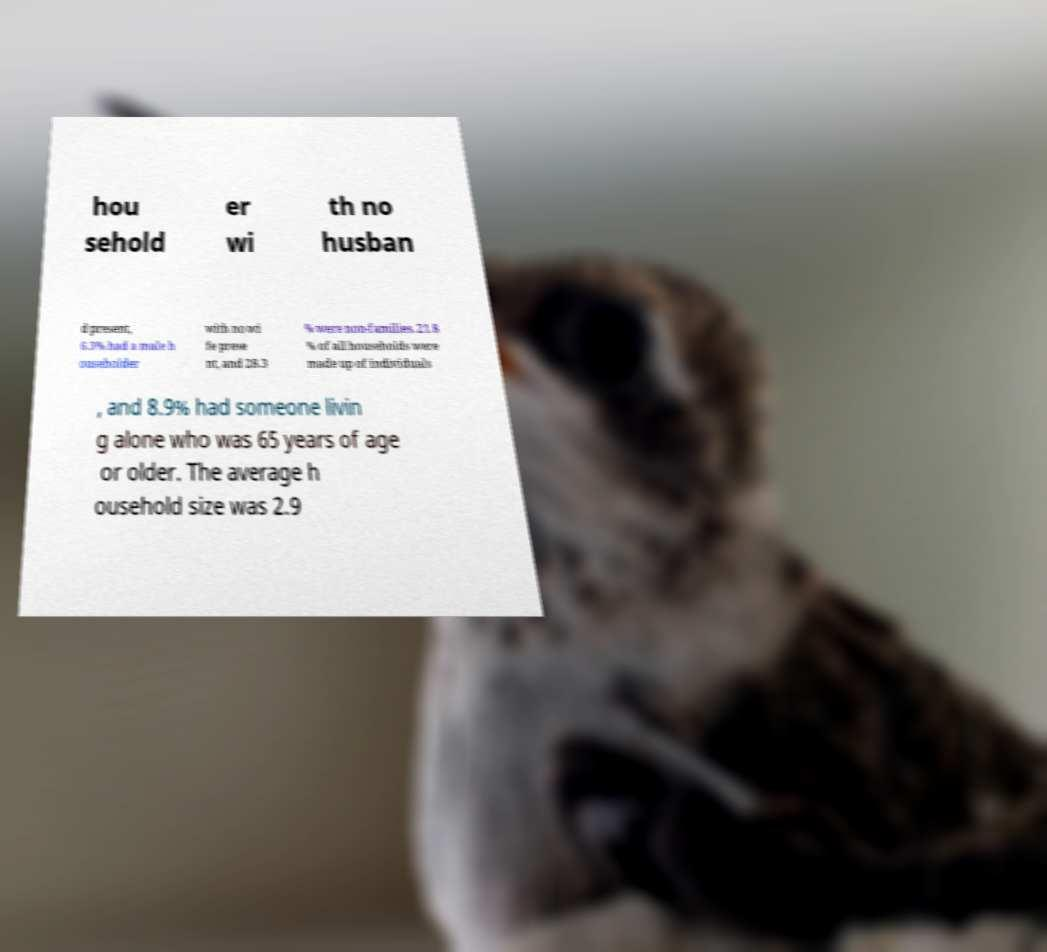Please read and relay the text visible in this image. What does it say? hou sehold er wi th no husban d present, 6.3% had a male h ouseholder with no wi fe prese nt, and 28.3 % were non-families. 21.8 % of all households were made up of individuals , and 8.9% had someone livin g alone who was 65 years of age or older. The average h ousehold size was 2.9 